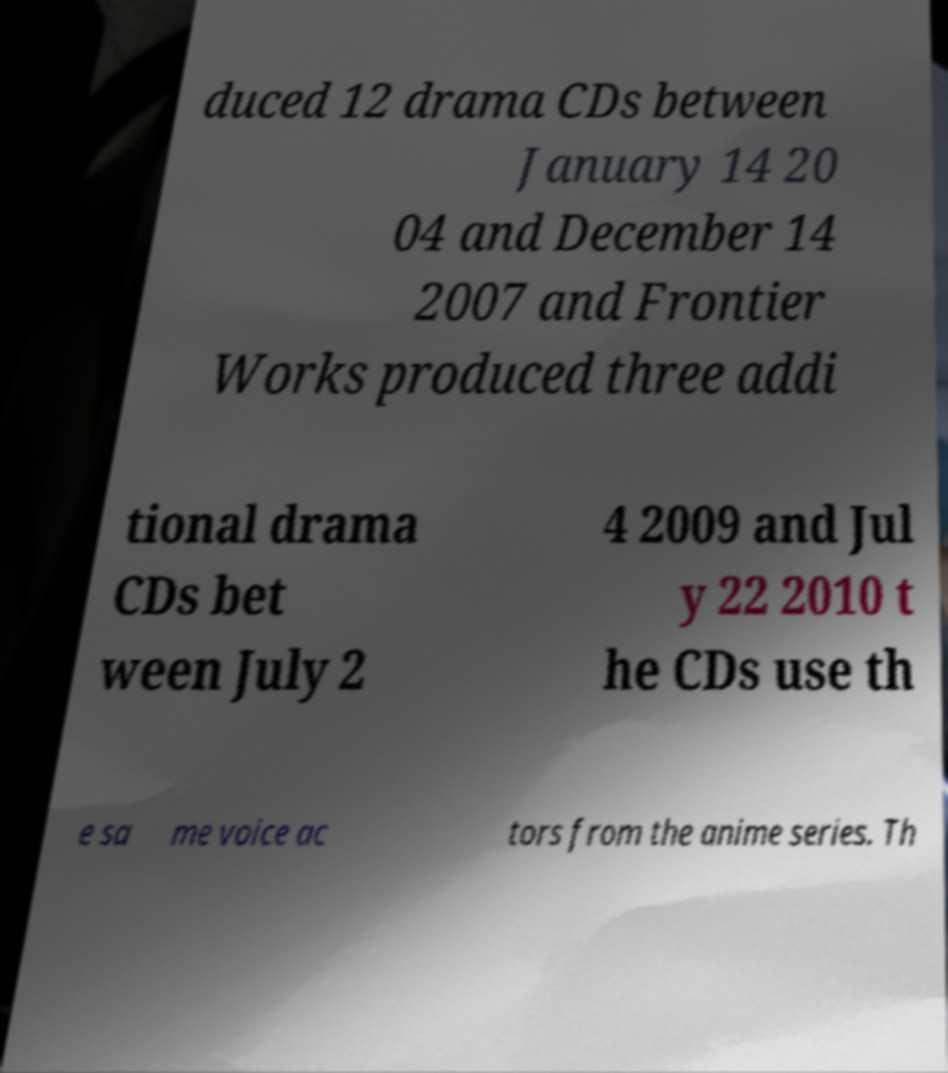There's text embedded in this image that I need extracted. Can you transcribe it verbatim? duced 12 drama CDs between January 14 20 04 and December 14 2007 and Frontier Works produced three addi tional drama CDs bet ween July 2 4 2009 and Jul y 22 2010 t he CDs use th e sa me voice ac tors from the anime series. Th 